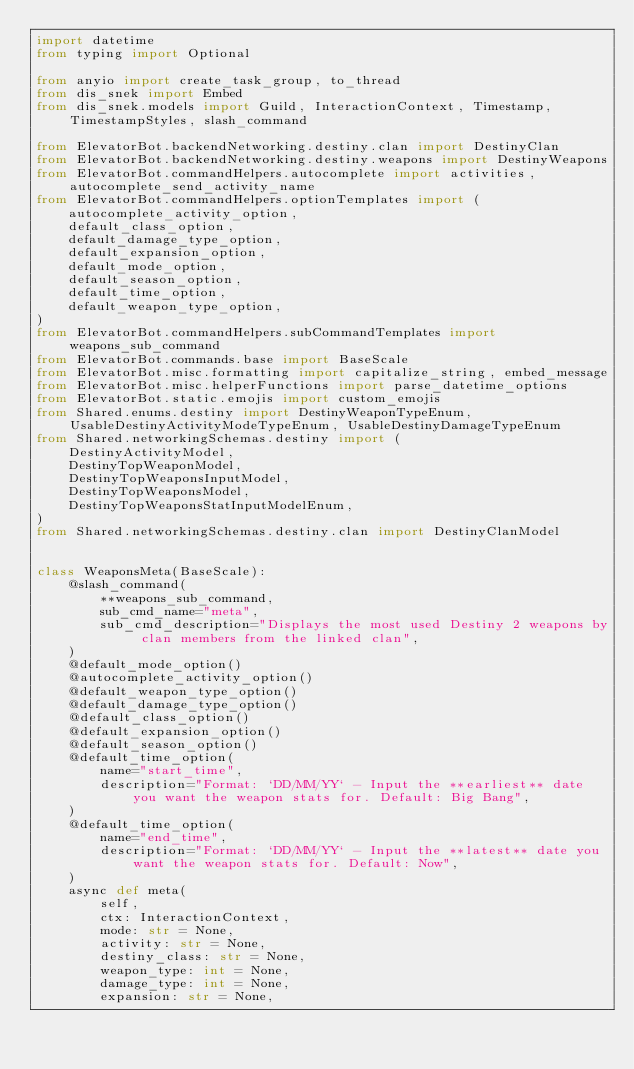<code> <loc_0><loc_0><loc_500><loc_500><_Python_>import datetime
from typing import Optional

from anyio import create_task_group, to_thread
from dis_snek import Embed
from dis_snek.models import Guild, InteractionContext, Timestamp, TimestampStyles, slash_command

from ElevatorBot.backendNetworking.destiny.clan import DestinyClan
from ElevatorBot.backendNetworking.destiny.weapons import DestinyWeapons
from ElevatorBot.commandHelpers.autocomplete import activities, autocomplete_send_activity_name
from ElevatorBot.commandHelpers.optionTemplates import (
    autocomplete_activity_option,
    default_class_option,
    default_damage_type_option,
    default_expansion_option,
    default_mode_option,
    default_season_option,
    default_time_option,
    default_weapon_type_option,
)
from ElevatorBot.commandHelpers.subCommandTemplates import weapons_sub_command
from ElevatorBot.commands.base import BaseScale
from ElevatorBot.misc.formatting import capitalize_string, embed_message
from ElevatorBot.misc.helperFunctions import parse_datetime_options
from ElevatorBot.static.emojis import custom_emojis
from Shared.enums.destiny import DestinyWeaponTypeEnum, UsableDestinyActivityModeTypeEnum, UsableDestinyDamageTypeEnum
from Shared.networkingSchemas.destiny import (
    DestinyActivityModel,
    DestinyTopWeaponModel,
    DestinyTopWeaponsInputModel,
    DestinyTopWeaponsModel,
    DestinyTopWeaponsStatInputModelEnum,
)
from Shared.networkingSchemas.destiny.clan import DestinyClanModel


class WeaponsMeta(BaseScale):
    @slash_command(
        **weapons_sub_command,
        sub_cmd_name="meta",
        sub_cmd_description="Displays the most used Destiny 2 weapons by clan members from the linked clan",
    )
    @default_mode_option()
    @autocomplete_activity_option()
    @default_weapon_type_option()
    @default_damage_type_option()
    @default_class_option()
    @default_expansion_option()
    @default_season_option()
    @default_time_option(
        name="start_time",
        description="Format: `DD/MM/YY` - Input the **earliest** date you want the weapon stats for. Default: Big Bang",
    )
    @default_time_option(
        name="end_time",
        description="Format: `DD/MM/YY` - Input the **latest** date you want the weapon stats for. Default: Now",
    )
    async def meta(
        self,
        ctx: InteractionContext,
        mode: str = None,
        activity: str = None,
        destiny_class: str = None,
        weapon_type: int = None,
        damage_type: int = None,
        expansion: str = None,</code> 